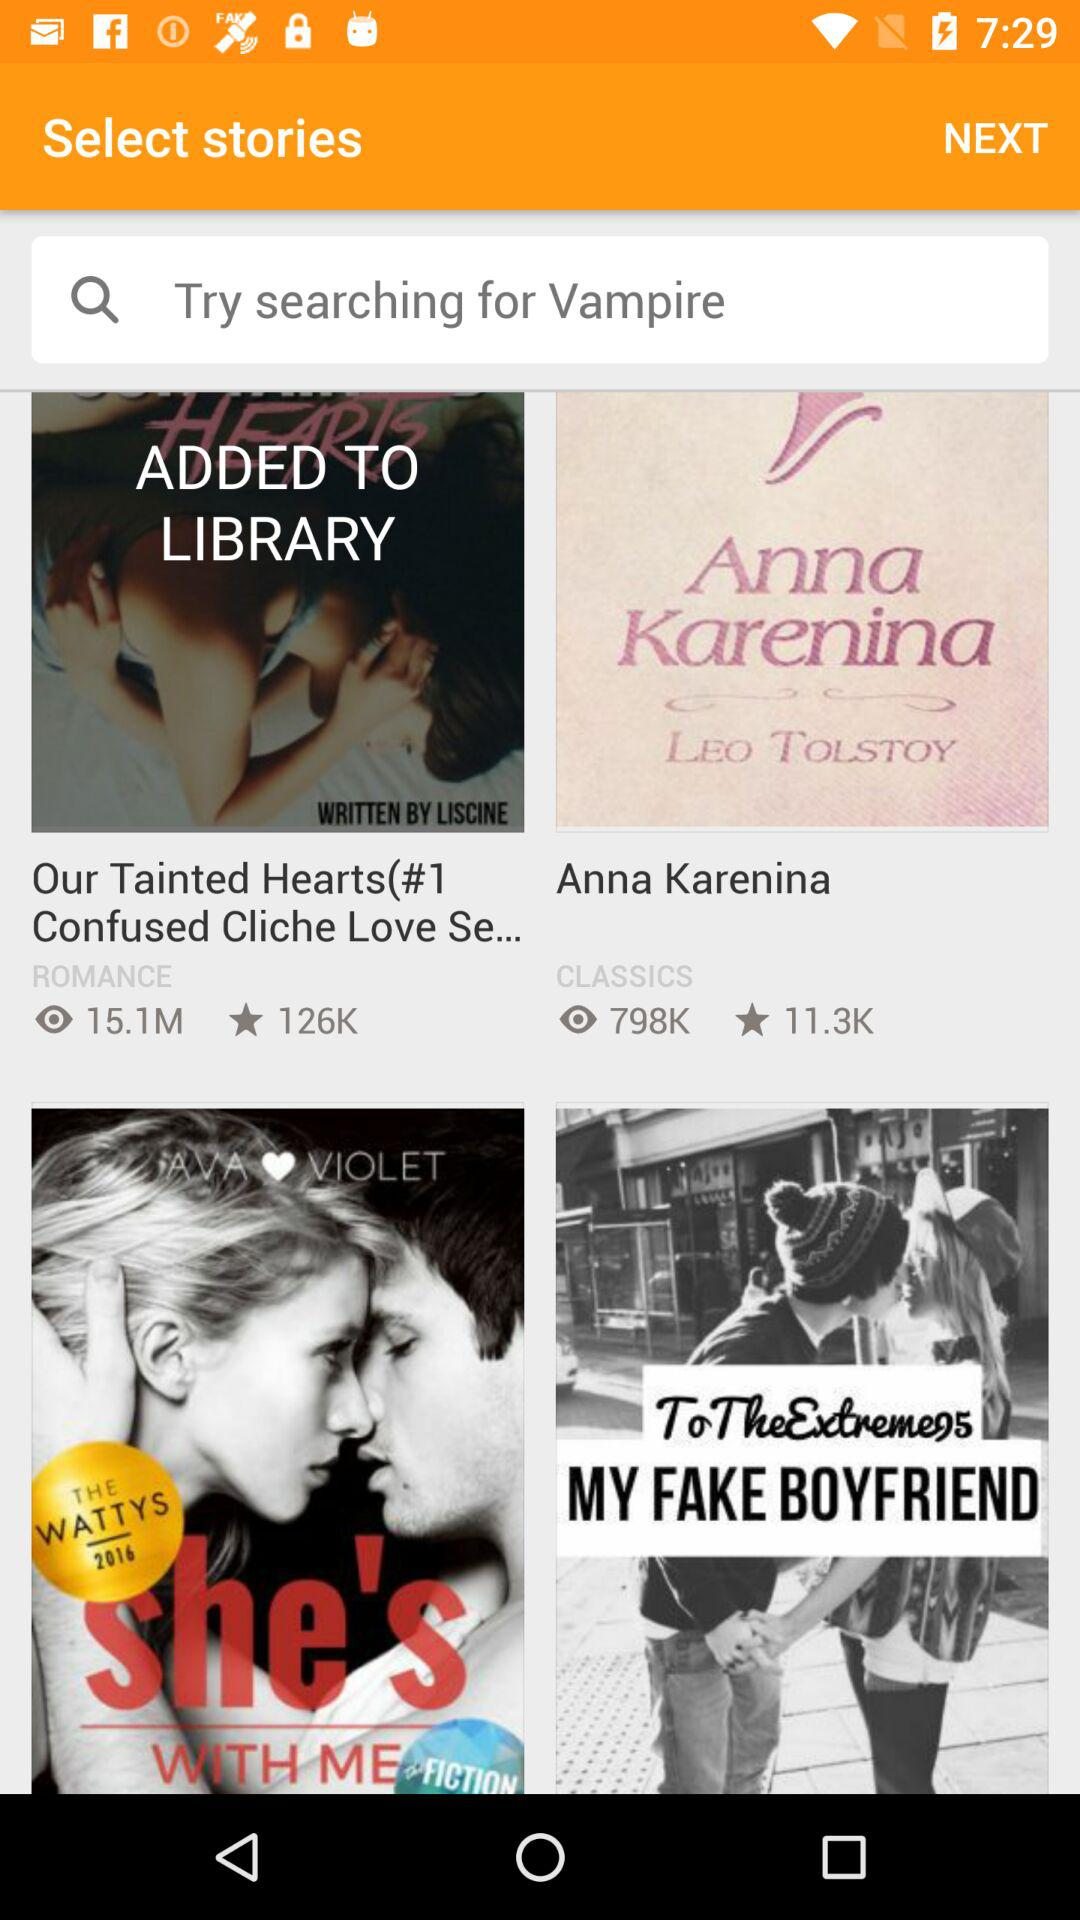Who has written "Our Tainted Hearts(#1 Confused Cliche Love Se..."? "Our Tainted Hearts(#1 Confused Cliche Love Se..." has been written by LISCINE. 